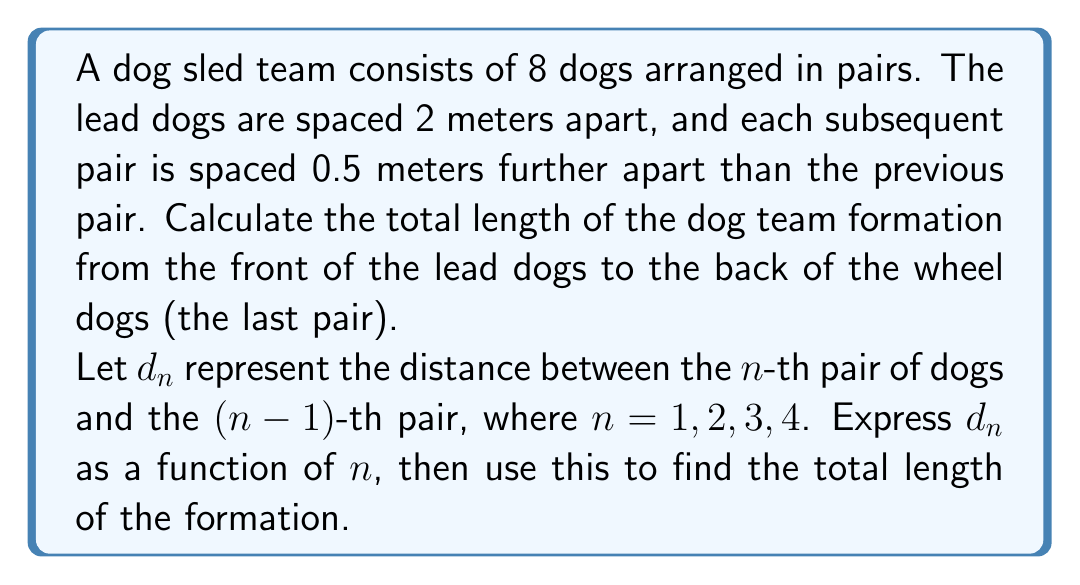Help me with this question. To solve this problem, we'll follow these steps:

1) First, let's express $d_n$ as a function of $n$:
   
   We know that the lead dogs (first pair) are 2 meters apart, and each subsequent pair is 0.5 meters further apart than the previous pair.
   
   So, $d_1 = 2$, $d_2 = 2.5$, $d_3 = 3$, $d_4 = 3.5$
   
   We can express this as: $d_n = 2 + 0.5(n-1)$ for $n = 1, 2, 3, 4$

2) Now, to find the total length, we need to sum these distances:

   Total length = $\sum_{n=1}^{4} d_n$

3) Let's expand this sum:

   $\sum_{n=1}^{4} d_n = \sum_{n=1}^{4} [2 + 0.5(n-1)]$
                       $= \sum_{n=1}^{4} 2 + 0.5 \sum_{n=1}^{4} (n-1)$
                       $= 4 \cdot 2 + 0.5 \sum_{n=1}^{4} (n-1)$
                       $= 8 + 0.5 (0 + 1 + 2 + 3)$
                       $= 8 + 0.5 \cdot 6$
                       $= 8 + 3$
                       $= 11$

Therefore, the total length of the dog team formation is 11 meters.
Answer: The total length of the dog team formation is 11 meters. 